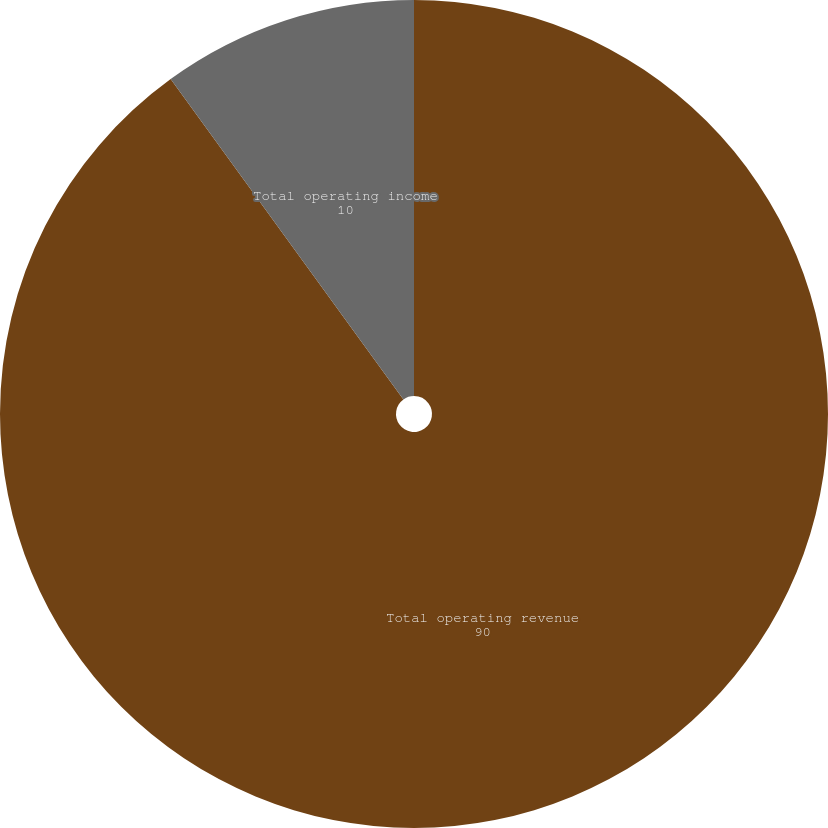Convert chart to OTSL. <chart><loc_0><loc_0><loc_500><loc_500><pie_chart><fcel>Total operating revenue<fcel>Total operating income<nl><fcel>90.0%<fcel>10.0%<nl></chart> 